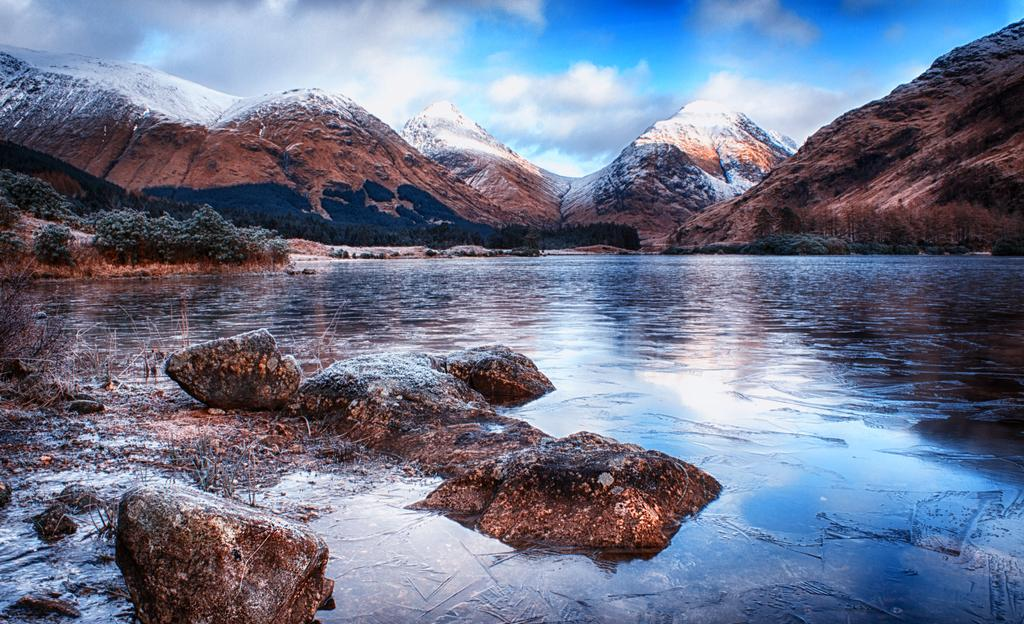What is located in the foreground of the image? There are rocks in the foreground of the image. What is surrounding the rocks in the image? There is a water surface around the rocks. What can be seen in the background of the image? There are plants and mountains in the background of the image. Where is the sister of the person taking the picture in the image? There is no person taking the picture or any reference to a sister in the image. What type of farming equipment can be seen in the image? There is no farming equipment present in the image. 